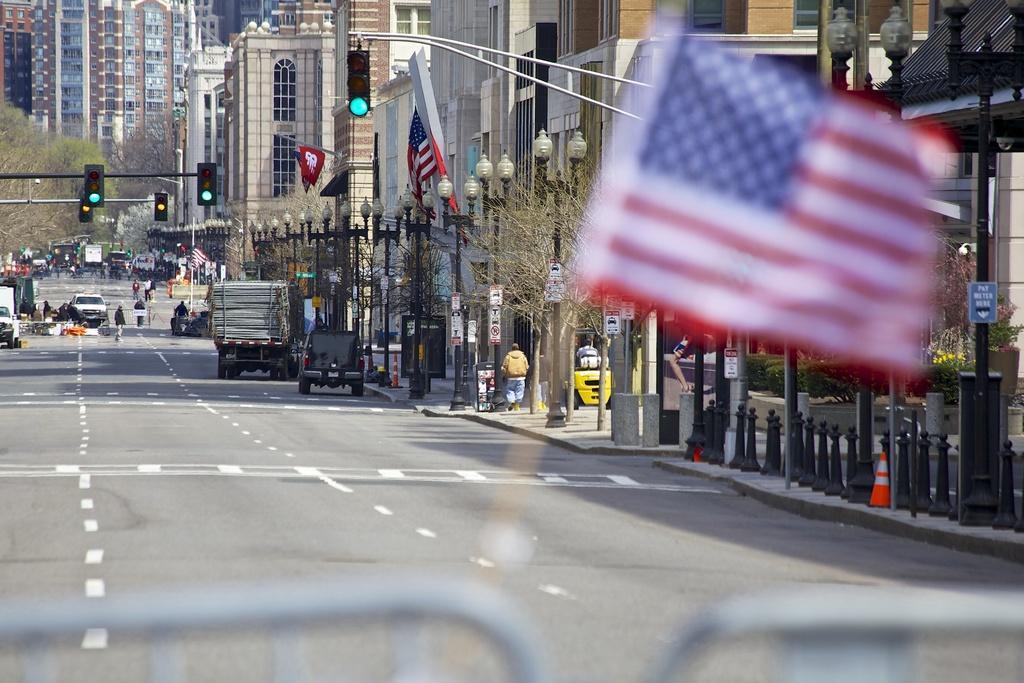Could you give a brief overview of what you see in this image? This is a street view. I can see buildings on the right side of the image I can see some flags and some light poles and some people on the road and some vehicles.  